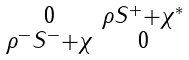Convert formula to latex. <formula><loc_0><loc_0><loc_500><loc_500>\begin{smallmatrix} 0 & \rho S ^ { + } + \chi ^ { * } \\ \rho ^ { - } S ^ { - } + \chi & 0 \end{smallmatrix}</formula> 